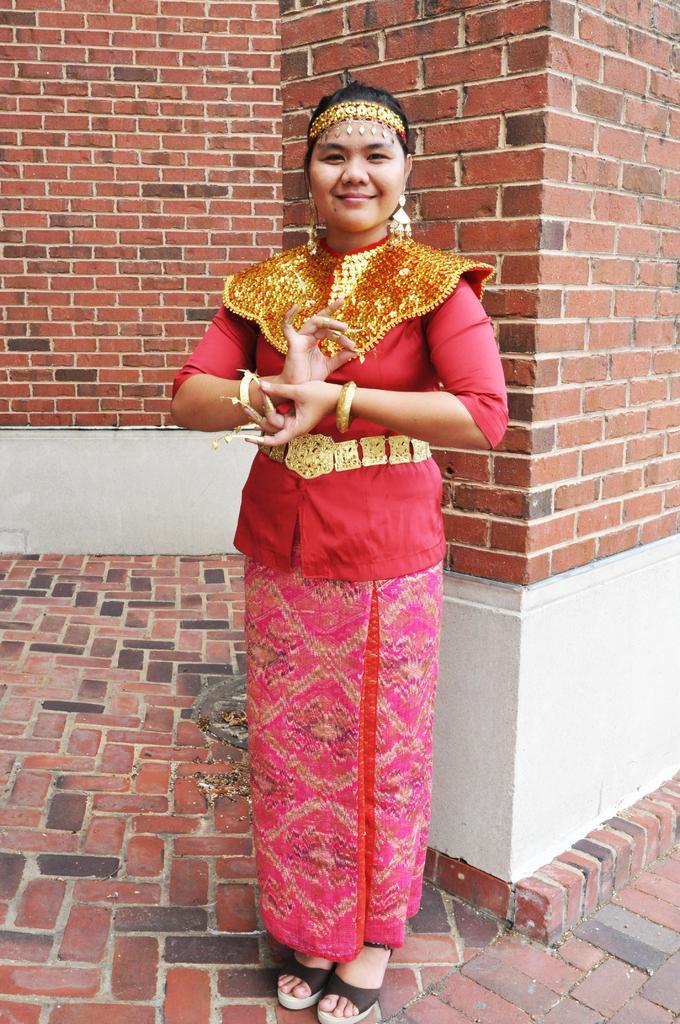How would you summarize this image in a sentence or two? In this image we can see a woman is standing on the floor at the brick wall. In the background we can see brick wall. 